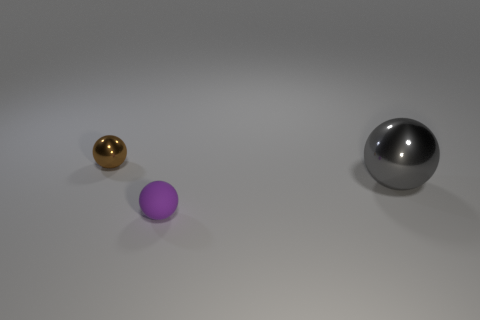Subtract all tiny spheres. How many spheres are left? 1 Add 1 large metal balls. How many objects exist? 4 Subtract all purple rubber cubes. Subtract all gray metal things. How many objects are left? 2 Add 3 small objects. How many small objects are left? 5 Add 3 gray things. How many gray things exist? 4 Subtract 1 brown spheres. How many objects are left? 2 